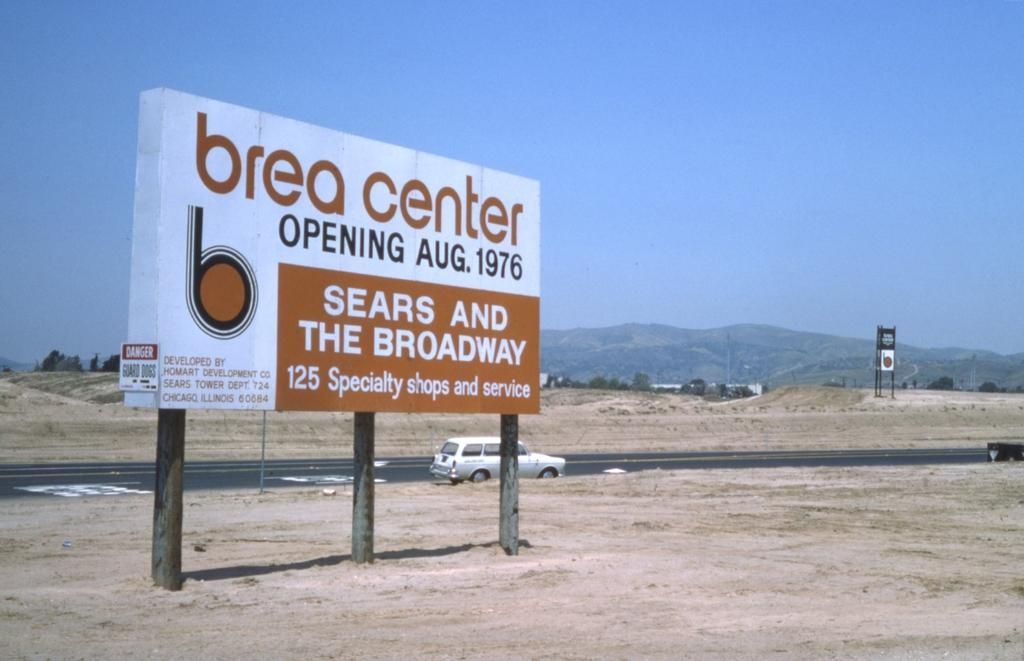<image>
Give a short and clear explanation of the subsequent image. A sign board with the text 'brea center' says that it is opening in August of 1976. 